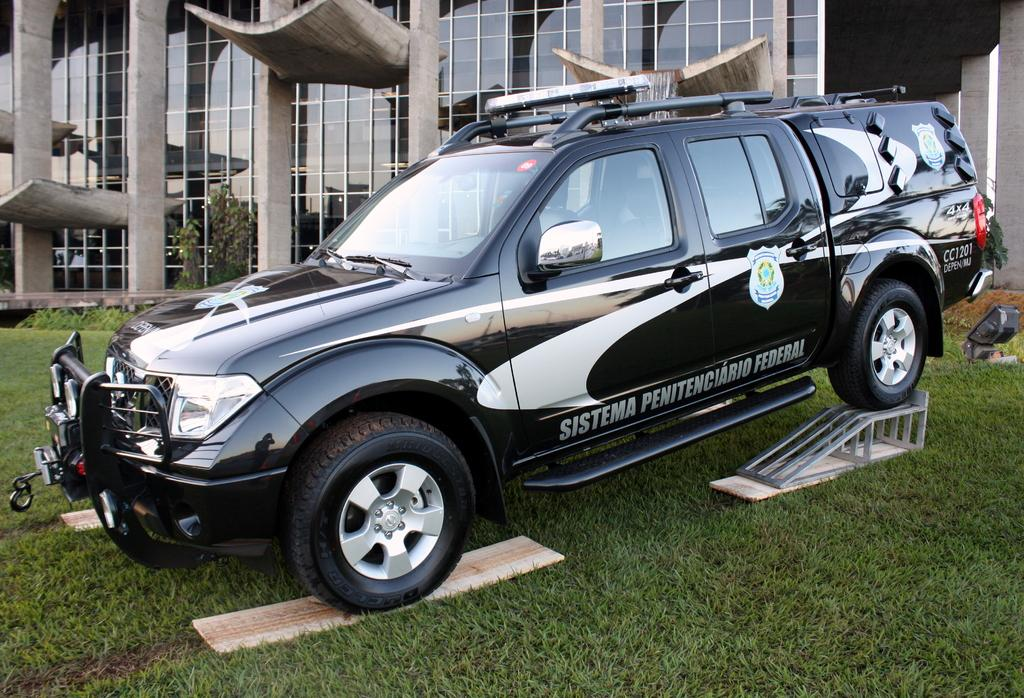What type of vehicle is on stand in the image? There is a vehicle on stand in the image, but the specific type is not mentioned. What is the ground surface like in the image? The ground has grass in the image. Can you describe the building in the image? There is a building with glass walls in the image. What other natural elements are present in the image? There are trees in the image. What is written or displayed on the vehicle? There is text or writing on the vehicle. How many casts are visible in the image? There are no casts present in the image. What type of quartz can be seen in the image? There is no quartz present in the image. 